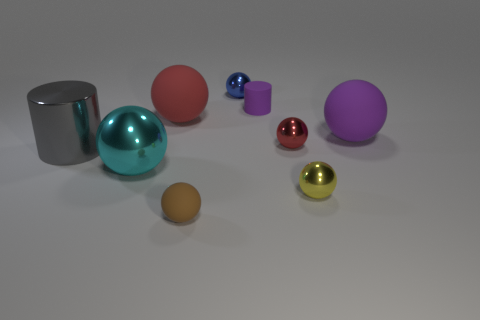Subtract all purple spheres. How many spheres are left? 6 Subtract all balls. How many objects are left? 2 Subtract 2 cylinders. How many cylinders are left? 0 Subtract all yellow spheres. Subtract all brown cubes. How many spheres are left? 6 Subtract all purple cylinders. How many gray balls are left? 0 Subtract all large red rubber spheres. Subtract all tiny purple things. How many objects are left? 7 Add 5 small purple matte cylinders. How many small purple matte cylinders are left? 6 Add 3 big gray metallic cylinders. How many big gray metallic cylinders exist? 4 Add 1 brown rubber spheres. How many objects exist? 10 Subtract all brown balls. How many balls are left? 6 